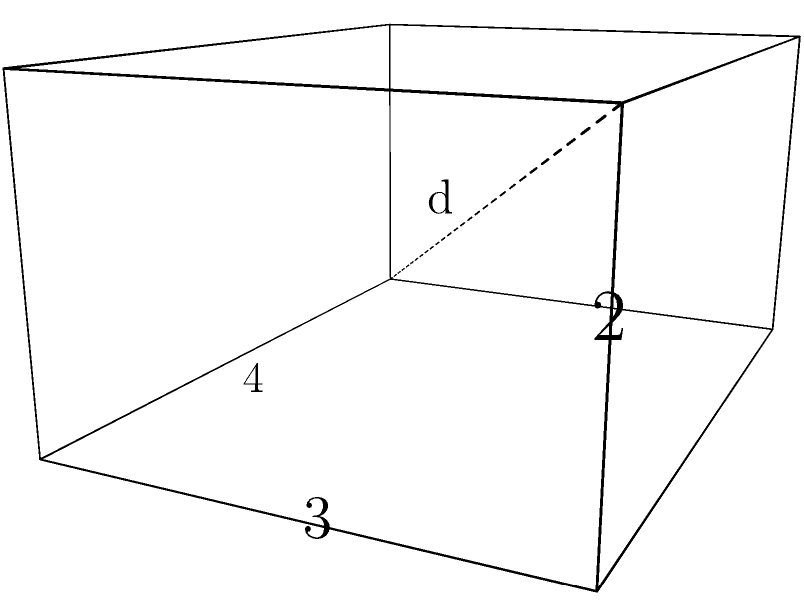In the temple, there is a rectangular altar with length 4 cubits, width 3 cubits, and height 2 cubits. What is the length of the diagonal from one corner to the opposite corner, symbolizing the connection between the earthly realm and the divine? Express your answer in cubits, rounded to two decimal places. To find the diagonal length of the rectangular altar, we can use the three-dimensional extension of the Pythagorean theorem. Let's approach this step-by-step:

1) In a rectangular solid, the diagonal forms the hypotenuse of a right triangle whose other two sides are:
   a) The diagonal of the base rectangle
   b) The height of the solid

2) First, let's find the diagonal of the base rectangle:
   $$d_{base}^2 = 4^2 + 3^2 = 16 + 9 = 25$$
   $$d_{base} = \sqrt{25} = 5$$

3) Now, we can use this base diagonal and the height to find the full diagonal:
   $$d^2 = 5^2 + 2^2 = 25 + 4 = 29$$

4) Taking the square root:
   $$d = \sqrt{29} \approx 5.3852$$

5) Rounding to two decimal places:
   $$d \approx 5.39$$

Thus, the diagonal of the altar, connecting the earthly realm to the divine, is approximately 5.39 cubits.
Answer: 5.39 cubits 